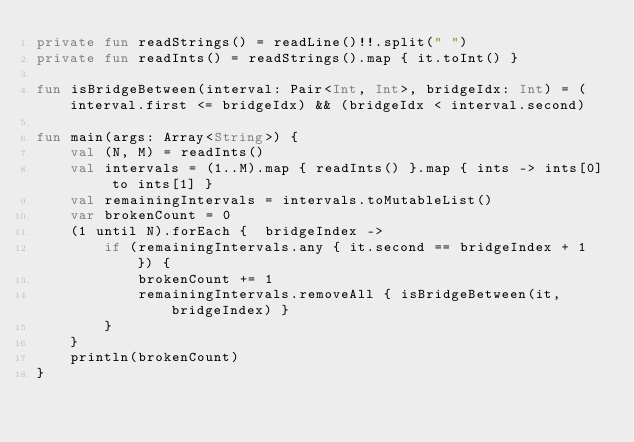<code> <loc_0><loc_0><loc_500><loc_500><_Kotlin_>private fun readStrings() = readLine()!!.split(" ")
private fun readInts() = readStrings().map { it.toInt() }

fun isBridgeBetween(interval: Pair<Int, Int>, bridgeIdx: Int) = (interval.first <= bridgeIdx) && (bridgeIdx < interval.second)

fun main(args: Array<String>) {
    val (N, M) = readInts()
    val intervals = (1..M).map { readInts() }.map { ints -> ints[0] to ints[1] }
    val remainingIntervals = intervals.toMutableList()
    var brokenCount = 0
    (1 until N).forEach {  bridgeIndex ->
        if (remainingIntervals.any { it.second == bridgeIndex + 1 }) {
            brokenCount += 1
            remainingIntervals.removeAll { isBridgeBetween(it, bridgeIndex) }
        }
    }
    println(brokenCount)
}</code> 